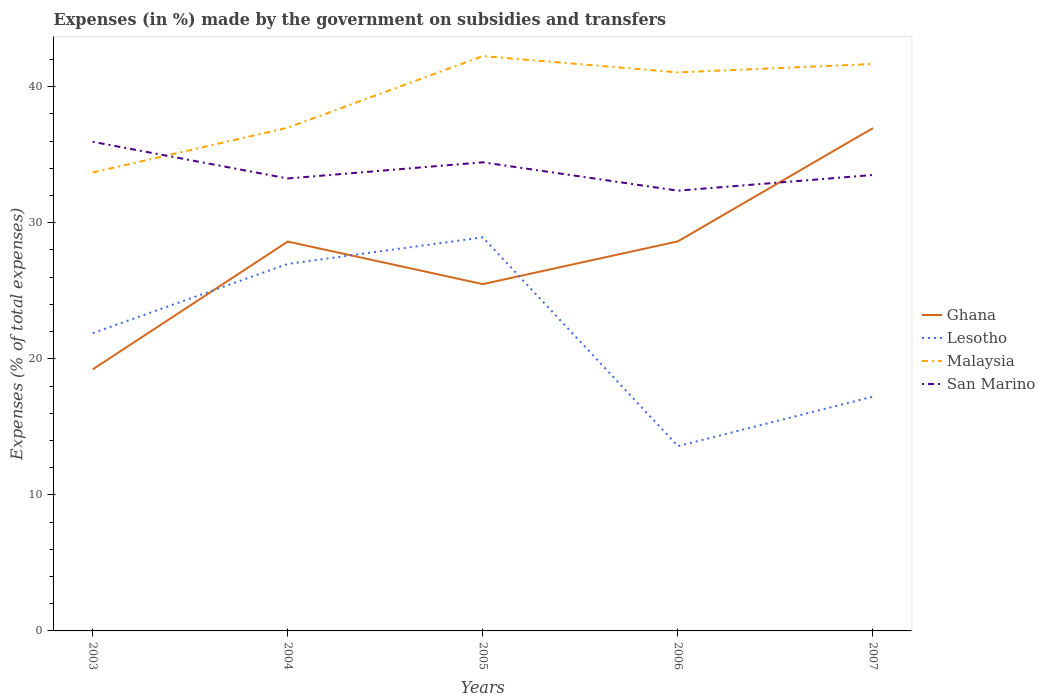Across all years, what is the maximum percentage of expenses made by the government on subsidies and transfers in San Marino?
Make the answer very short. 32.36. In which year was the percentage of expenses made by the government on subsidies and transfers in San Marino maximum?
Provide a succinct answer. 2006. What is the total percentage of expenses made by the government on subsidies and transfers in Lesotho in the graph?
Your answer should be very brief. 9.75. What is the difference between the highest and the second highest percentage of expenses made by the government on subsidies and transfers in Ghana?
Your answer should be compact. 17.74. Does the graph contain grids?
Your answer should be very brief. No. Where does the legend appear in the graph?
Offer a terse response. Center right. How are the legend labels stacked?
Give a very brief answer. Vertical. What is the title of the graph?
Your response must be concise. Expenses (in %) made by the government on subsidies and transfers. What is the label or title of the Y-axis?
Give a very brief answer. Expenses (% of total expenses). What is the Expenses (% of total expenses) in Ghana in 2003?
Keep it short and to the point. 19.23. What is the Expenses (% of total expenses) of Lesotho in 2003?
Your answer should be very brief. 21.89. What is the Expenses (% of total expenses) of Malaysia in 2003?
Ensure brevity in your answer.  33.7. What is the Expenses (% of total expenses) of San Marino in 2003?
Provide a short and direct response. 35.95. What is the Expenses (% of total expenses) of Ghana in 2004?
Offer a terse response. 28.62. What is the Expenses (% of total expenses) of Lesotho in 2004?
Your answer should be very brief. 26.98. What is the Expenses (% of total expenses) of Malaysia in 2004?
Ensure brevity in your answer.  36.99. What is the Expenses (% of total expenses) in San Marino in 2004?
Ensure brevity in your answer.  33.26. What is the Expenses (% of total expenses) of Ghana in 2005?
Keep it short and to the point. 25.49. What is the Expenses (% of total expenses) of Lesotho in 2005?
Ensure brevity in your answer.  28.93. What is the Expenses (% of total expenses) of Malaysia in 2005?
Offer a terse response. 42.25. What is the Expenses (% of total expenses) in San Marino in 2005?
Make the answer very short. 34.45. What is the Expenses (% of total expenses) in Ghana in 2006?
Your response must be concise. 28.63. What is the Expenses (% of total expenses) of Lesotho in 2006?
Your answer should be compact. 13.58. What is the Expenses (% of total expenses) in Malaysia in 2006?
Ensure brevity in your answer.  41.06. What is the Expenses (% of total expenses) in San Marino in 2006?
Ensure brevity in your answer.  32.36. What is the Expenses (% of total expenses) in Ghana in 2007?
Offer a very short reply. 36.96. What is the Expenses (% of total expenses) in Lesotho in 2007?
Your response must be concise. 17.23. What is the Expenses (% of total expenses) in Malaysia in 2007?
Offer a terse response. 41.67. What is the Expenses (% of total expenses) of San Marino in 2007?
Your answer should be compact. 33.51. Across all years, what is the maximum Expenses (% of total expenses) of Ghana?
Ensure brevity in your answer.  36.96. Across all years, what is the maximum Expenses (% of total expenses) in Lesotho?
Ensure brevity in your answer.  28.93. Across all years, what is the maximum Expenses (% of total expenses) of Malaysia?
Offer a terse response. 42.25. Across all years, what is the maximum Expenses (% of total expenses) in San Marino?
Your answer should be compact. 35.95. Across all years, what is the minimum Expenses (% of total expenses) in Ghana?
Provide a succinct answer. 19.23. Across all years, what is the minimum Expenses (% of total expenses) in Lesotho?
Your answer should be very brief. 13.58. Across all years, what is the minimum Expenses (% of total expenses) of Malaysia?
Provide a short and direct response. 33.7. Across all years, what is the minimum Expenses (% of total expenses) of San Marino?
Provide a short and direct response. 32.36. What is the total Expenses (% of total expenses) of Ghana in the graph?
Ensure brevity in your answer.  138.93. What is the total Expenses (% of total expenses) in Lesotho in the graph?
Offer a terse response. 108.6. What is the total Expenses (% of total expenses) of Malaysia in the graph?
Provide a succinct answer. 195.67. What is the total Expenses (% of total expenses) of San Marino in the graph?
Your answer should be compact. 169.53. What is the difference between the Expenses (% of total expenses) in Ghana in 2003 and that in 2004?
Keep it short and to the point. -9.39. What is the difference between the Expenses (% of total expenses) of Lesotho in 2003 and that in 2004?
Your answer should be very brief. -5.09. What is the difference between the Expenses (% of total expenses) in Malaysia in 2003 and that in 2004?
Offer a terse response. -3.3. What is the difference between the Expenses (% of total expenses) of San Marino in 2003 and that in 2004?
Your answer should be very brief. 2.7. What is the difference between the Expenses (% of total expenses) of Ghana in 2003 and that in 2005?
Make the answer very short. -6.27. What is the difference between the Expenses (% of total expenses) in Lesotho in 2003 and that in 2005?
Keep it short and to the point. -7.04. What is the difference between the Expenses (% of total expenses) in Malaysia in 2003 and that in 2005?
Ensure brevity in your answer.  -8.56. What is the difference between the Expenses (% of total expenses) in San Marino in 2003 and that in 2005?
Offer a very short reply. 1.51. What is the difference between the Expenses (% of total expenses) in Ghana in 2003 and that in 2006?
Provide a short and direct response. -9.41. What is the difference between the Expenses (% of total expenses) in Lesotho in 2003 and that in 2006?
Provide a succinct answer. 8.31. What is the difference between the Expenses (% of total expenses) in Malaysia in 2003 and that in 2006?
Give a very brief answer. -7.36. What is the difference between the Expenses (% of total expenses) in San Marino in 2003 and that in 2006?
Your answer should be compact. 3.59. What is the difference between the Expenses (% of total expenses) in Ghana in 2003 and that in 2007?
Your response must be concise. -17.74. What is the difference between the Expenses (% of total expenses) of Lesotho in 2003 and that in 2007?
Your answer should be compact. 4.66. What is the difference between the Expenses (% of total expenses) in Malaysia in 2003 and that in 2007?
Your response must be concise. -7.97. What is the difference between the Expenses (% of total expenses) of San Marino in 2003 and that in 2007?
Your answer should be compact. 2.44. What is the difference between the Expenses (% of total expenses) of Ghana in 2004 and that in 2005?
Make the answer very short. 3.13. What is the difference between the Expenses (% of total expenses) of Lesotho in 2004 and that in 2005?
Offer a terse response. -1.95. What is the difference between the Expenses (% of total expenses) in Malaysia in 2004 and that in 2005?
Your answer should be compact. -5.26. What is the difference between the Expenses (% of total expenses) in San Marino in 2004 and that in 2005?
Offer a terse response. -1.19. What is the difference between the Expenses (% of total expenses) of Ghana in 2004 and that in 2006?
Give a very brief answer. -0.01. What is the difference between the Expenses (% of total expenses) of Lesotho in 2004 and that in 2006?
Provide a short and direct response. 13.4. What is the difference between the Expenses (% of total expenses) of Malaysia in 2004 and that in 2006?
Your answer should be very brief. -4.06. What is the difference between the Expenses (% of total expenses) in San Marino in 2004 and that in 2006?
Provide a succinct answer. 0.9. What is the difference between the Expenses (% of total expenses) of Ghana in 2004 and that in 2007?
Ensure brevity in your answer.  -8.34. What is the difference between the Expenses (% of total expenses) in Lesotho in 2004 and that in 2007?
Provide a succinct answer. 9.75. What is the difference between the Expenses (% of total expenses) in Malaysia in 2004 and that in 2007?
Offer a terse response. -4.68. What is the difference between the Expenses (% of total expenses) of San Marino in 2004 and that in 2007?
Ensure brevity in your answer.  -0.26. What is the difference between the Expenses (% of total expenses) of Ghana in 2005 and that in 2006?
Your answer should be very brief. -3.14. What is the difference between the Expenses (% of total expenses) in Lesotho in 2005 and that in 2006?
Give a very brief answer. 15.35. What is the difference between the Expenses (% of total expenses) in Malaysia in 2005 and that in 2006?
Offer a very short reply. 1.2. What is the difference between the Expenses (% of total expenses) of San Marino in 2005 and that in 2006?
Your response must be concise. 2.08. What is the difference between the Expenses (% of total expenses) of Ghana in 2005 and that in 2007?
Offer a very short reply. -11.47. What is the difference between the Expenses (% of total expenses) in Lesotho in 2005 and that in 2007?
Make the answer very short. 11.7. What is the difference between the Expenses (% of total expenses) of Malaysia in 2005 and that in 2007?
Your answer should be very brief. 0.58. What is the difference between the Expenses (% of total expenses) in San Marino in 2005 and that in 2007?
Offer a very short reply. 0.93. What is the difference between the Expenses (% of total expenses) in Ghana in 2006 and that in 2007?
Make the answer very short. -8.33. What is the difference between the Expenses (% of total expenses) in Lesotho in 2006 and that in 2007?
Give a very brief answer. -3.65. What is the difference between the Expenses (% of total expenses) of Malaysia in 2006 and that in 2007?
Offer a very short reply. -0.61. What is the difference between the Expenses (% of total expenses) in San Marino in 2006 and that in 2007?
Provide a succinct answer. -1.15. What is the difference between the Expenses (% of total expenses) of Ghana in 2003 and the Expenses (% of total expenses) of Lesotho in 2004?
Ensure brevity in your answer.  -7.75. What is the difference between the Expenses (% of total expenses) in Ghana in 2003 and the Expenses (% of total expenses) in Malaysia in 2004?
Your answer should be very brief. -17.77. What is the difference between the Expenses (% of total expenses) in Ghana in 2003 and the Expenses (% of total expenses) in San Marino in 2004?
Your response must be concise. -14.03. What is the difference between the Expenses (% of total expenses) of Lesotho in 2003 and the Expenses (% of total expenses) of Malaysia in 2004?
Provide a short and direct response. -15.1. What is the difference between the Expenses (% of total expenses) in Lesotho in 2003 and the Expenses (% of total expenses) in San Marino in 2004?
Your answer should be compact. -11.37. What is the difference between the Expenses (% of total expenses) of Malaysia in 2003 and the Expenses (% of total expenses) of San Marino in 2004?
Offer a terse response. 0.44. What is the difference between the Expenses (% of total expenses) of Ghana in 2003 and the Expenses (% of total expenses) of Lesotho in 2005?
Provide a short and direct response. -9.7. What is the difference between the Expenses (% of total expenses) in Ghana in 2003 and the Expenses (% of total expenses) in Malaysia in 2005?
Make the answer very short. -23.03. What is the difference between the Expenses (% of total expenses) of Ghana in 2003 and the Expenses (% of total expenses) of San Marino in 2005?
Your response must be concise. -15.22. What is the difference between the Expenses (% of total expenses) in Lesotho in 2003 and the Expenses (% of total expenses) in Malaysia in 2005?
Give a very brief answer. -20.36. What is the difference between the Expenses (% of total expenses) in Lesotho in 2003 and the Expenses (% of total expenses) in San Marino in 2005?
Your response must be concise. -12.56. What is the difference between the Expenses (% of total expenses) in Malaysia in 2003 and the Expenses (% of total expenses) in San Marino in 2005?
Your answer should be very brief. -0.75. What is the difference between the Expenses (% of total expenses) of Ghana in 2003 and the Expenses (% of total expenses) of Lesotho in 2006?
Make the answer very short. 5.65. What is the difference between the Expenses (% of total expenses) of Ghana in 2003 and the Expenses (% of total expenses) of Malaysia in 2006?
Make the answer very short. -21.83. What is the difference between the Expenses (% of total expenses) of Ghana in 2003 and the Expenses (% of total expenses) of San Marino in 2006?
Your answer should be very brief. -13.14. What is the difference between the Expenses (% of total expenses) in Lesotho in 2003 and the Expenses (% of total expenses) in Malaysia in 2006?
Keep it short and to the point. -19.17. What is the difference between the Expenses (% of total expenses) of Lesotho in 2003 and the Expenses (% of total expenses) of San Marino in 2006?
Ensure brevity in your answer.  -10.47. What is the difference between the Expenses (% of total expenses) of Malaysia in 2003 and the Expenses (% of total expenses) of San Marino in 2006?
Provide a short and direct response. 1.33. What is the difference between the Expenses (% of total expenses) in Ghana in 2003 and the Expenses (% of total expenses) in Lesotho in 2007?
Offer a terse response. 2. What is the difference between the Expenses (% of total expenses) in Ghana in 2003 and the Expenses (% of total expenses) in Malaysia in 2007?
Offer a very short reply. -22.44. What is the difference between the Expenses (% of total expenses) of Ghana in 2003 and the Expenses (% of total expenses) of San Marino in 2007?
Provide a short and direct response. -14.29. What is the difference between the Expenses (% of total expenses) in Lesotho in 2003 and the Expenses (% of total expenses) in Malaysia in 2007?
Your answer should be compact. -19.78. What is the difference between the Expenses (% of total expenses) of Lesotho in 2003 and the Expenses (% of total expenses) of San Marino in 2007?
Make the answer very short. -11.62. What is the difference between the Expenses (% of total expenses) in Malaysia in 2003 and the Expenses (% of total expenses) in San Marino in 2007?
Keep it short and to the point. 0.18. What is the difference between the Expenses (% of total expenses) of Ghana in 2004 and the Expenses (% of total expenses) of Lesotho in 2005?
Your answer should be very brief. -0.31. What is the difference between the Expenses (% of total expenses) of Ghana in 2004 and the Expenses (% of total expenses) of Malaysia in 2005?
Make the answer very short. -13.63. What is the difference between the Expenses (% of total expenses) in Ghana in 2004 and the Expenses (% of total expenses) in San Marino in 2005?
Ensure brevity in your answer.  -5.83. What is the difference between the Expenses (% of total expenses) in Lesotho in 2004 and the Expenses (% of total expenses) in Malaysia in 2005?
Your response must be concise. -15.28. What is the difference between the Expenses (% of total expenses) in Lesotho in 2004 and the Expenses (% of total expenses) in San Marino in 2005?
Your answer should be compact. -7.47. What is the difference between the Expenses (% of total expenses) in Malaysia in 2004 and the Expenses (% of total expenses) in San Marino in 2005?
Provide a succinct answer. 2.55. What is the difference between the Expenses (% of total expenses) of Ghana in 2004 and the Expenses (% of total expenses) of Lesotho in 2006?
Your answer should be compact. 15.04. What is the difference between the Expenses (% of total expenses) in Ghana in 2004 and the Expenses (% of total expenses) in Malaysia in 2006?
Offer a very short reply. -12.44. What is the difference between the Expenses (% of total expenses) in Ghana in 2004 and the Expenses (% of total expenses) in San Marino in 2006?
Give a very brief answer. -3.74. What is the difference between the Expenses (% of total expenses) in Lesotho in 2004 and the Expenses (% of total expenses) in Malaysia in 2006?
Your response must be concise. -14.08. What is the difference between the Expenses (% of total expenses) in Lesotho in 2004 and the Expenses (% of total expenses) in San Marino in 2006?
Make the answer very short. -5.38. What is the difference between the Expenses (% of total expenses) in Malaysia in 2004 and the Expenses (% of total expenses) in San Marino in 2006?
Your response must be concise. 4.63. What is the difference between the Expenses (% of total expenses) in Ghana in 2004 and the Expenses (% of total expenses) in Lesotho in 2007?
Ensure brevity in your answer.  11.39. What is the difference between the Expenses (% of total expenses) of Ghana in 2004 and the Expenses (% of total expenses) of Malaysia in 2007?
Provide a short and direct response. -13.05. What is the difference between the Expenses (% of total expenses) of Ghana in 2004 and the Expenses (% of total expenses) of San Marino in 2007?
Offer a very short reply. -4.89. What is the difference between the Expenses (% of total expenses) of Lesotho in 2004 and the Expenses (% of total expenses) of Malaysia in 2007?
Offer a terse response. -14.69. What is the difference between the Expenses (% of total expenses) of Lesotho in 2004 and the Expenses (% of total expenses) of San Marino in 2007?
Your answer should be compact. -6.54. What is the difference between the Expenses (% of total expenses) of Malaysia in 2004 and the Expenses (% of total expenses) of San Marino in 2007?
Give a very brief answer. 3.48. What is the difference between the Expenses (% of total expenses) in Ghana in 2005 and the Expenses (% of total expenses) in Lesotho in 2006?
Ensure brevity in your answer.  11.91. What is the difference between the Expenses (% of total expenses) in Ghana in 2005 and the Expenses (% of total expenses) in Malaysia in 2006?
Give a very brief answer. -15.56. What is the difference between the Expenses (% of total expenses) of Ghana in 2005 and the Expenses (% of total expenses) of San Marino in 2006?
Offer a terse response. -6.87. What is the difference between the Expenses (% of total expenses) of Lesotho in 2005 and the Expenses (% of total expenses) of Malaysia in 2006?
Your answer should be very brief. -12.13. What is the difference between the Expenses (% of total expenses) in Lesotho in 2005 and the Expenses (% of total expenses) in San Marino in 2006?
Give a very brief answer. -3.43. What is the difference between the Expenses (% of total expenses) in Malaysia in 2005 and the Expenses (% of total expenses) in San Marino in 2006?
Give a very brief answer. 9.89. What is the difference between the Expenses (% of total expenses) of Ghana in 2005 and the Expenses (% of total expenses) of Lesotho in 2007?
Provide a short and direct response. 8.27. What is the difference between the Expenses (% of total expenses) in Ghana in 2005 and the Expenses (% of total expenses) in Malaysia in 2007?
Your response must be concise. -16.18. What is the difference between the Expenses (% of total expenses) of Ghana in 2005 and the Expenses (% of total expenses) of San Marino in 2007?
Your response must be concise. -8.02. What is the difference between the Expenses (% of total expenses) of Lesotho in 2005 and the Expenses (% of total expenses) of Malaysia in 2007?
Give a very brief answer. -12.74. What is the difference between the Expenses (% of total expenses) of Lesotho in 2005 and the Expenses (% of total expenses) of San Marino in 2007?
Make the answer very short. -4.58. What is the difference between the Expenses (% of total expenses) in Malaysia in 2005 and the Expenses (% of total expenses) in San Marino in 2007?
Ensure brevity in your answer.  8.74. What is the difference between the Expenses (% of total expenses) in Ghana in 2006 and the Expenses (% of total expenses) in Lesotho in 2007?
Make the answer very short. 11.41. What is the difference between the Expenses (% of total expenses) of Ghana in 2006 and the Expenses (% of total expenses) of Malaysia in 2007?
Your answer should be very brief. -13.04. What is the difference between the Expenses (% of total expenses) in Ghana in 2006 and the Expenses (% of total expenses) in San Marino in 2007?
Make the answer very short. -4.88. What is the difference between the Expenses (% of total expenses) in Lesotho in 2006 and the Expenses (% of total expenses) in Malaysia in 2007?
Your response must be concise. -28.09. What is the difference between the Expenses (% of total expenses) of Lesotho in 2006 and the Expenses (% of total expenses) of San Marino in 2007?
Give a very brief answer. -19.93. What is the difference between the Expenses (% of total expenses) of Malaysia in 2006 and the Expenses (% of total expenses) of San Marino in 2007?
Make the answer very short. 7.54. What is the average Expenses (% of total expenses) of Ghana per year?
Give a very brief answer. 27.79. What is the average Expenses (% of total expenses) of Lesotho per year?
Your answer should be very brief. 21.72. What is the average Expenses (% of total expenses) in Malaysia per year?
Offer a terse response. 39.13. What is the average Expenses (% of total expenses) in San Marino per year?
Ensure brevity in your answer.  33.91. In the year 2003, what is the difference between the Expenses (% of total expenses) of Ghana and Expenses (% of total expenses) of Lesotho?
Keep it short and to the point. -2.66. In the year 2003, what is the difference between the Expenses (% of total expenses) of Ghana and Expenses (% of total expenses) of Malaysia?
Provide a succinct answer. -14.47. In the year 2003, what is the difference between the Expenses (% of total expenses) in Ghana and Expenses (% of total expenses) in San Marino?
Keep it short and to the point. -16.73. In the year 2003, what is the difference between the Expenses (% of total expenses) of Lesotho and Expenses (% of total expenses) of Malaysia?
Offer a very short reply. -11.81. In the year 2003, what is the difference between the Expenses (% of total expenses) of Lesotho and Expenses (% of total expenses) of San Marino?
Make the answer very short. -14.06. In the year 2003, what is the difference between the Expenses (% of total expenses) of Malaysia and Expenses (% of total expenses) of San Marino?
Ensure brevity in your answer.  -2.26. In the year 2004, what is the difference between the Expenses (% of total expenses) of Ghana and Expenses (% of total expenses) of Lesotho?
Provide a short and direct response. 1.64. In the year 2004, what is the difference between the Expenses (% of total expenses) of Ghana and Expenses (% of total expenses) of Malaysia?
Your answer should be very brief. -8.37. In the year 2004, what is the difference between the Expenses (% of total expenses) in Ghana and Expenses (% of total expenses) in San Marino?
Your response must be concise. -4.64. In the year 2004, what is the difference between the Expenses (% of total expenses) of Lesotho and Expenses (% of total expenses) of Malaysia?
Give a very brief answer. -10.02. In the year 2004, what is the difference between the Expenses (% of total expenses) in Lesotho and Expenses (% of total expenses) in San Marino?
Offer a very short reply. -6.28. In the year 2004, what is the difference between the Expenses (% of total expenses) in Malaysia and Expenses (% of total expenses) in San Marino?
Provide a short and direct response. 3.73. In the year 2005, what is the difference between the Expenses (% of total expenses) in Ghana and Expenses (% of total expenses) in Lesotho?
Make the answer very short. -3.44. In the year 2005, what is the difference between the Expenses (% of total expenses) of Ghana and Expenses (% of total expenses) of Malaysia?
Ensure brevity in your answer.  -16.76. In the year 2005, what is the difference between the Expenses (% of total expenses) in Ghana and Expenses (% of total expenses) in San Marino?
Provide a succinct answer. -8.96. In the year 2005, what is the difference between the Expenses (% of total expenses) in Lesotho and Expenses (% of total expenses) in Malaysia?
Provide a succinct answer. -13.32. In the year 2005, what is the difference between the Expenses (% of total expenses) of Lesotho and Expenses (% of total expenses) of San Marino?
Provide a succinct answer. -5.52. In the year 2005, what is the difference between the Expenses (% of total expenses) of Malaysia and Expenses (% of total expenses) of San Marino?
Offer a terse response. 7.81. In the year 2006, what is the difference between the Expenses (% of total expenses) in Ghana and Expenses (% of total expenses) in Lesotho?
Provide a succinct answer. 15.05. In the year 2006, what is the difference between the Expenses (% of total expenses) in Ghana and Expenses (% of total expenses) in Malaysia?
Offer a very short reply. -12.42. In the year 2006, what is the difference between the Expenses (% of total expenses) in Ghana and Expenses (% of total expenses) in San Marino?
Your answer should be compact. -3.73. In the year 2006, what is the difference between the Expenses (% of total expenses) of Lesotho and Expenses (% of total expenses) of Malaysia?
Ensure brevity in your answer.  -27.48. In the year 2006, what is the difference between the Expenses (% of total expenses) in Lesotho and Expenses (% of total expenses) in San Marino?
Offer a terse response. -18.78. In the year 2006, what is the difference between the Expenses (% of total expenses) of Malaysia and Expenses (% of total expenses) of San Marino?
Offer a very short reply. 8.69. In the year 2007, what is the difference between the Expenses (% of total expenses) in Ghana and Expenses (% of total expenses) in Lesotho?
Your answer should be very brief. 19.74. In the year 2007, what is the difference between the Expenses (% of total expenses) of Ghana and Expenses (% of total expenses) of Malaysia?
Give a very brief answer. -4.71. In the year 2007, what is the difference between the Expenses (% of total expenses) in Ghana and Expenses (% of total expenses) in San Marino?
Give a very brief answer. 3.45. In the year 2007, what is the difference between the Expenses (% of total expenses) in Lesotho and Expenses (% of total expenses) in Malaysia?
Provide a succinct answer. -24.45. In the year 2007, what is the difference between the Expenses (% of total expenses) in Lesotho and Expenses (% of total expenses) in San Marino?
Keep it short and to the point. -16.29. In the year 2007, what is the difference between the Expenses (% of total expenses) of Malaysia and Expenses (% of total expenses) of San Marino?
Your response must be concise. 8.16. What is the ratio of the Expenses (% of total expenses) in Ghana in 2003 to that in 2004?
Give a very brief answer. 0.67. What is the ratio of the Expenses (% of total expenses) in Lesotho in 2003 to that in 2004?
Your answer should be very brief. 0.81. What is the ratio of the Expenses (% of total expenses) of Malaysia in 2003 to that in 2004?
Your answer should be very brief. 0.91. What is the ratio of the Expenses (% of total expenses) in San Marino in 2003 to that in 2004?
Your answer should be compact. 1.08. What is the ratio of the Expenses (% of total expenses) in Ghana in 2003 to that in 2005?
Your response must be concise. 0.75. What is the ratio of the Expenses (% of total expenses) in Lesotho in 2003 to that in 2005?
Your answer should be compact. 0.76. What is the ratio of the Expenses (% of total expenses) of Malaysia in 2003 to that in 2005?
Give a very brief answer. 0.8. What is the ratio of the Expenses (% of total expenses) of San Marino in 2003 to that in 2005?
Offer a very short reply. 1.04. What is the ratio of the Expenses (% of total expenses) in Ghana in 2003 to that in 2006?
Your response must be concise. 0.67. What is the ratio of the Expenses (% of total expenses) in Lesotho in 2003 to that in 2006?
Your answer should be very brief. 1.61. What is the ratio of the Expenses (% of total expenses) in Malaysia in 2003 to that in 2006?
Make the answer very short. 0.82. What is the ratio of the Expenses (% of total expenses) in San Marino in 2003 to that in 2006?
Ensure brevity in your answer.  1.11. What is the ratio of the Expenses (% of total expenses) of Ghana in 2003 to that in 2007?
Give a very brief answer. 0.52. What is the ratio of the Expenses (% of total expenses) in Lesotho in 2003 to that in 2007?
Provide a short and direct response. 1.27. What is the ratio of the Expenses (% of total expenses) in Malaysia in 2003 to that in 2007?
Ensure brevity in your answer.  0.81. What is the ratio of the Expenses (% of total expenses) in San Marino in 2003 to that in 2007?
Provide a succinct answer. 1.07. What is the ratio of the Expenses (% of total expenses) in Ghana in 2004 to that in 2005?
Offer a terse response. 1.12. What is the ratio of the Expenses (% of total expenses) of Lesotho in 2004 to that in 2005?
Keep it short and to the point. 0.93. What is the ratio of the Expenses (% of total expenses) in Malaysia in 2004 to that in 2005?
Offer a very short reply. 0.88. What is the ratio of the Expenses (% of total expenses) in San Marino in 2004 to that in 2005?
Your response must be concise. 0.97. What is the ratio of the Expenses (% of total expenses) in Lesotho in 2004 to that in 2006?
Give a very brief answer. 1.99. What is the ratio of the Expenses (% of total expenses) in Malaysia in 2004 to that in 2006?
Provide a short and direct response. 0.9. What is the ratio of the Expenses (% of total expenses) in San Marino in 2004 to that in 2006?
Give a very brief answer. 1.03. What is the ratio of the Expenses (% of total expenses) of Ghana in 2004 to that in 2007?
Keep it short and to the point. 0.77. What is the ratio of the Expenses (% of total expenses) of Lesotho in 2004 to that in 2007?
Your answer should be compact. 1.57. What is the ratio of the Expenses (% of total expenses) of Malaysia in 2004 to that in 2007?
Offer a very short reply. 0.89. What is the ratio of the Expenses (% of total expenses) in San Marino in 2004 to that in 2007?
Your answer should be compact. 0.99. What is the ratio of the Expenses (% of total expenses) in Ghana in 2005 to that in 2006?
Make the answer very short. 0.89. What is the ratio of the Expenses (% of total expenses) of Lesotho in 2005 to that in 2006?
Offer a terse response. 2.13. What is the ratio of the Expenses (% of total expenses) of Malaysia in 2005 to that in 2006?
Provide a succinct answer. 1.03. What is the ratio of the Expenses (% of total expenses) of San Marino in 2005 to that in 2006?
Provide a succinct answer. 1.06. What is the ratio of the Expenses (% of total expenses) of Ghana in 2005 to that in 2007?
Your response must be concise. 0.69. What is the ratio of the Expenses (% of total expenses) in Lesotho in 2005 to that in 2007?
Offer a terse response. 1.68. What is the ratio of the Expenses (% of total expenses) in Malaysia in 2005 to that in 2007?
Your response must be concise. 1.01. What is the ratio of the Expenses (% of total expenses) in San Marino in 2005 to that in 2007?
Offer a very short reply. 1.03. What is the ratio of the Expenses (% of total expenses) of Ghana in 2006 to that in 2007?
Your response must be concise. 0.77. What is the ratio of the Expenses (% of total expenses) in Lesotho in 2006 to that in 2007?
Your response must be concise. 0.79. What is the ratio of the Expenses (% of total expenses) in Malaysia in 2006 to that in 2007?
Ensure brevity in your answer.  0.99. What is the ratio of the Expenses (% of total expenses) of San Marino in 2006 to that in 2007?
Keep it short and to the point. 0.97. What is the difference between the highest and the second highest Expenses (% of total expenses) in Ghana?
Offer a very short reply. 8.33. What is the difference between the highest and the second highest Expenses (% of total expenses) in Lesotho?
Your response must be concise. 1.95. What is the difference between the highest and the second highest Expenses (% of total expenses) in Malaysia?
Your response must be concise. 0.58. What is the difference between the highest and the second highest Expenses (% of total expenses) of San Marino?
Your answer should be very brief. 1.51. What is the difference between the highest and the lowest Expenses (% of total expenses) of Ghana?
Keep it short and to the point. 17.74. What is the difference between the highest and the lowest Expenses (% of total expenses) of Lesotho?
Offer a very short reply. 15.35. What is the difference between the highest and the lowest Expenses (% of total expenses) in Malaysia?
Offer a very short reply. 8.56. What is the difference between the highest and the lowest Expenses (% of total expenses) in San Marino?
Give a very brief answer. 3.59. 